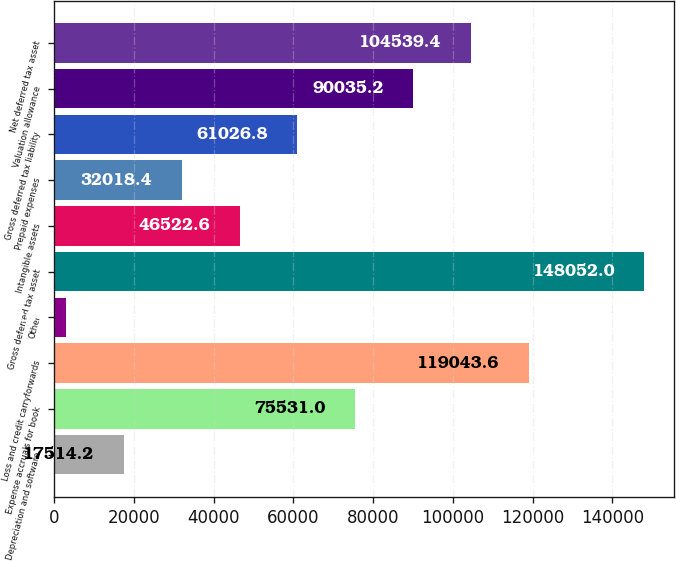Convert chart. <chart><loc_0><loc_0><loc_500><loc_500><bar_chart><fcel>Depreciation and software<fcel>Expense accruals for book<fcel>Loss and credit carryforwards<fcel>Other<fcel>Gross deferred tax asset<fcel>Intangible assets<fcel>Prepaid expenses<fcel>Gross deferred tax liability<fcel>Valuation allowance<fcel>Net deferred tax asset<nl><fcel>17514.2<fcel>75531<fcel>119044<fcel>3010<fcel>148052<fcel>46522.6<fcel>32018.4<fcel>61026.8<fcel>90035.2<fcel>104539<nl></chart> 